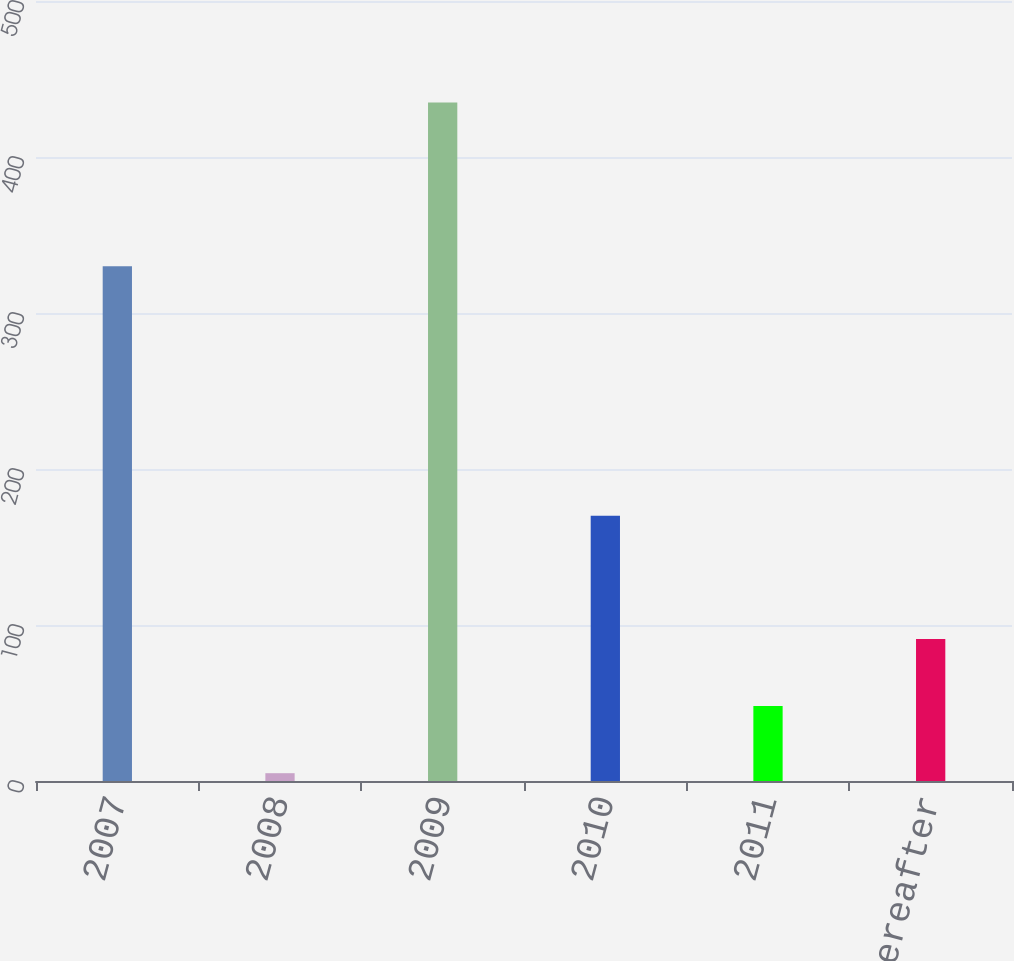<chart> <loc_0><loc_0><loc_500><loc_500><bar_chart><fcel>2007<fcel>2008<fcel>2009<fcel>2010<fcel>2011<fcel>Thereafter<nl><fcel>330<fcel>5<fcel>435<fcel>170<fcel>48<fcel>91<nl></chart> 